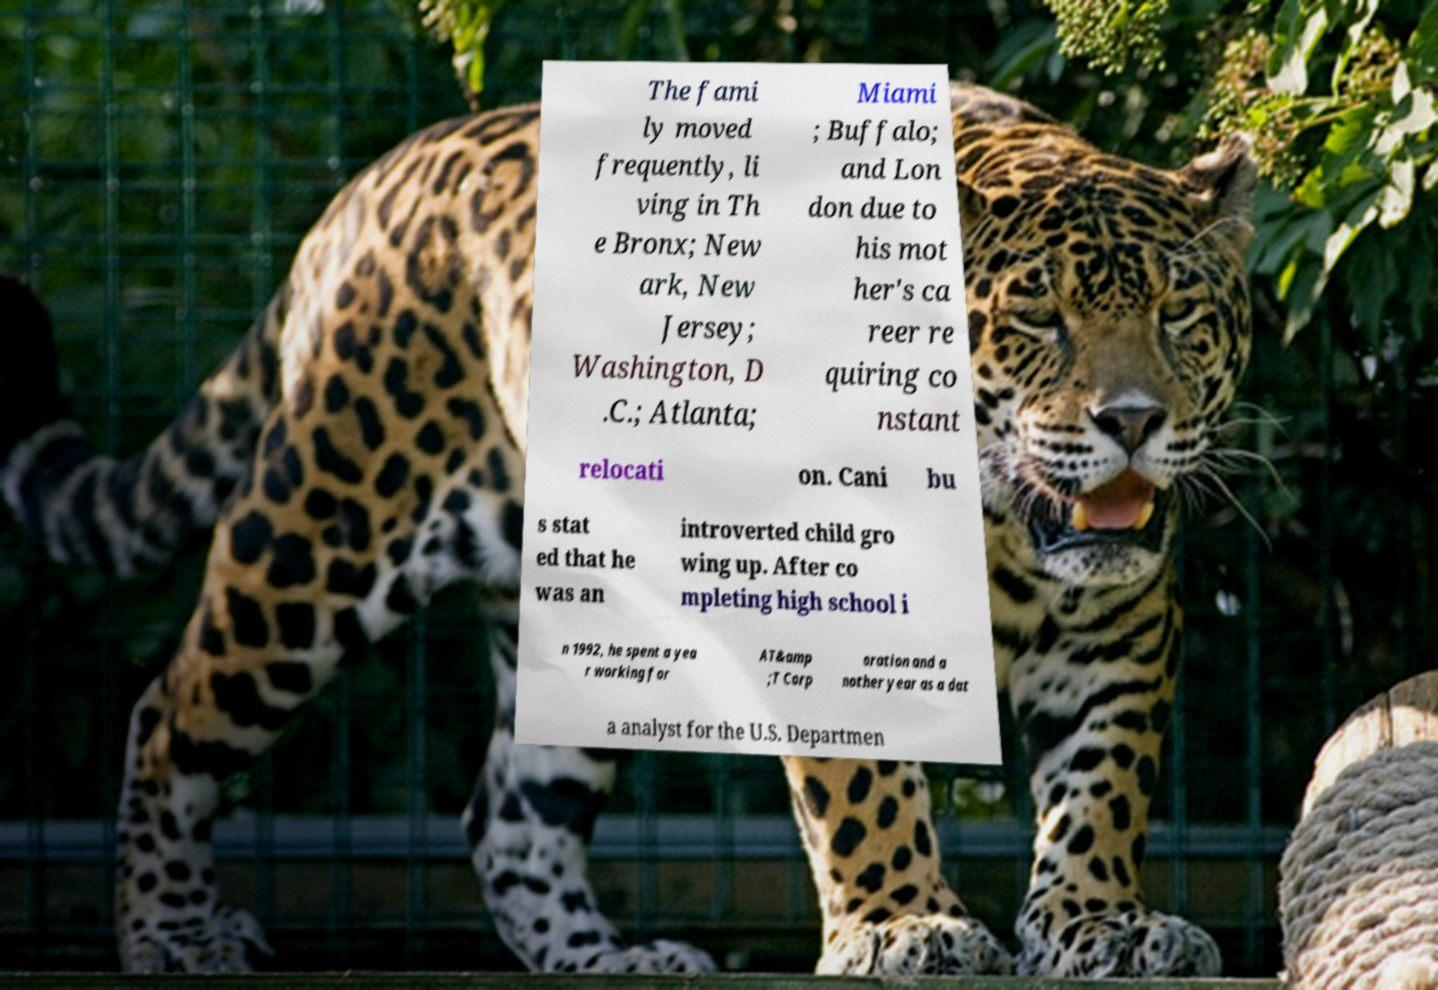Please identify and transcribe the text found in this image. The fami ly moved frequently, li ving in Th e Bronx; New ark, New Jersey; Washington, D .C.; Atlanta; Miami ; Buffalo; and Lon don due to his mot her's ca reer re quiring co nstant relocati on. Cani bu s stat ed that he was an introverted child gro wing up. After co mpleting high school i n 1992, he spent a yea r working for AT&amp ;T Corp oration and a nother year as a dat a analyst for the U.S. Departmen 